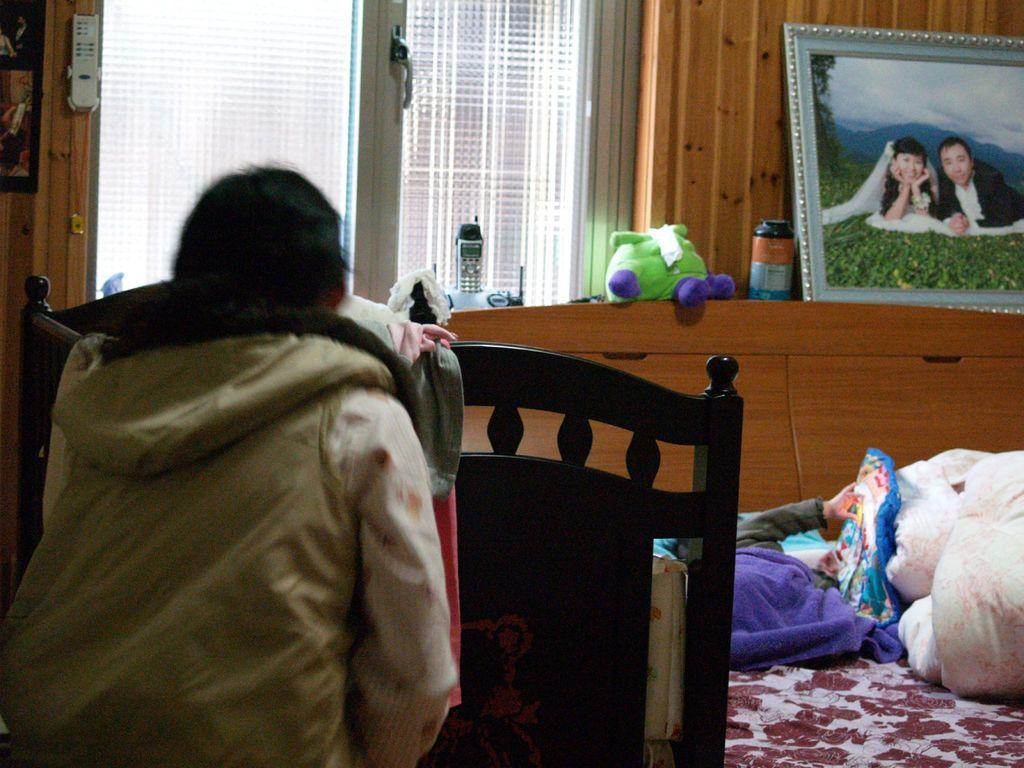Who or what is present in the image? There is a person in the image. What is the person near or on in the image? There is near or on a bed in the image. What is the purpose of the frame in the image? The frame in the image is likely for the window, as it is common to have frames around windows. What can be seen through the window in the image? There is a window in the image, but the facts do not specify what can be seen through it. What type of toy is in the image? The facts do not specify the type of toy in the image. What type of nerve can be seen in the image? There is no nerve visible in the image; it features a person, a bed, a frame, a window, and a toy. 